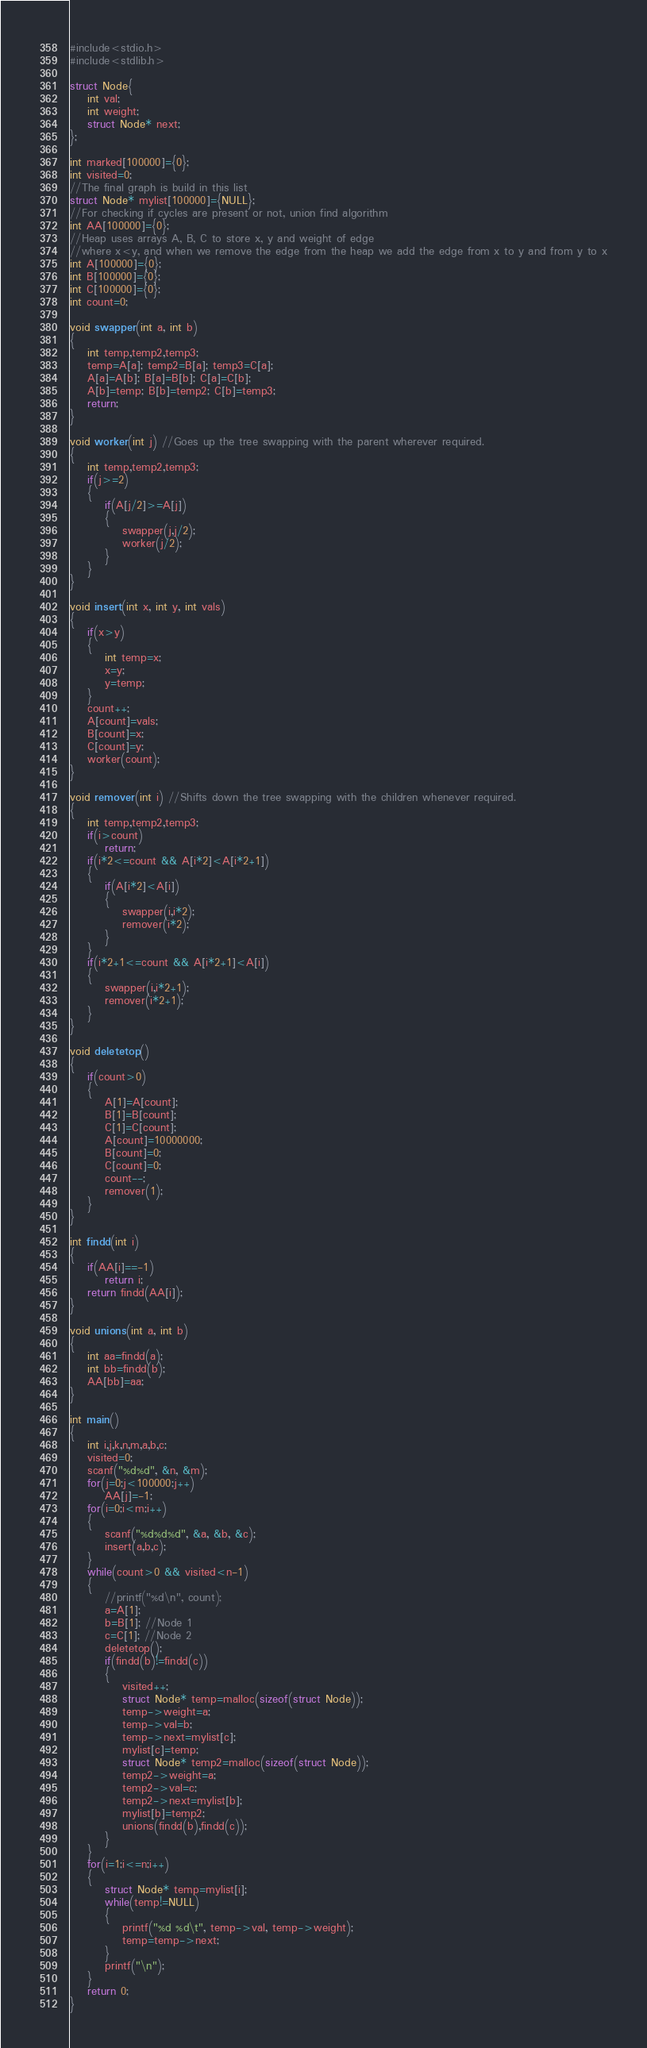Convert code to text. <code><loc_0><loc_0><loc_500><loc_500><_C_>#include<stdio.h>
#include<stdlib.h>

struct Node{
	int val;
	int weight;
	struct Node* next;
};

int marked[100000]={0};
int visited=0;
//The final graph is build in this list
struct Node* mylist[100000]={NULL};
//For checking if cycles are present or not, union find algorithm
int AA[100000]={0};
//Heap uses arrays A, B, C to store x, y and weight of edge
//where x<y, and when we remove the edge from the heap we add the edge from x to y and from y to x
int A[100000]={0};
int B[100000]={0};
int C[100000]={0};
int count=0;

void swapper(int a, int b)
{
	int temp,temp2,temp3;
	temp=A[a]; temp2=B[a]; temp3=C[a];
	A[a]=A[b]; B[a]=B[b]; C[a]=C[b];
	A[b]=temp; B[b]=temp2; C[b]=temp3;
	return;
}

void worker(int j) //Goes up the tree swapping with the parent wherever required.
{
	int temp,temp2,temp3;
	if(j>=2)
	{
		if(A[j/2]>=A[j])
		{
			swapper(j,j/2);
			worker(j/2);
		}
	}
}

void insert(int x, int y, int vals)
{
	if(x>y)
	{
		int temp=x;
		x=y;
		y=temp;
	}
	count++;
	A[count]=vals;
	B[count]=x;
	C[count]=y;
	worker(count);
}

void remover(int i) //Shifts down the tree swapping with the children whenever required.
{
	int temp,temp2,temp3;
	if(i>count)
		return;
	if(i*2<=count && A[i*2]<A[i*2+1])
	{
		if(A[i*2]<A[i])
		{
			swapper(i,i*2);
			remover(i*2);
		}
	}
	if(i*2+1<=count && A[i*2+1]<A[i])
	{
		swapper(i,i*2+1);
		remover(i*2+1);
	}
}

void deletetop()
{
	if(count>0)
	{
		A[1]=A[count];
		B[1]=B[count];
		C[1]=C[count];
		A[count]=10000000;
		B[count]=0;
		C[count]=0;
		count--;
		remover(1);
	}
}

int findd(int i)
{
	if(AA[i]==-1)
		return i;
	return findd(AA[i]);
}

void unions(int a, int b)
{
	int aa=findd(a);
	int bb=findd(b);
	AA[bb]=aa;
}

int main()
{
	int i,j,k,n,m,a,b,c;
	visited=0;
	scanf("%d%d", &n, &m);
	for(j=0;j<100000;j++)
		AA[j]=-1;
	for(i=0;i<m;i++)
	{
		scanf("%d%d%d", &a, &b, &c);
		insert(a,b,c);
	}
	while(count>0 && visited<n-1)
	{
		//printf("%d\n", count);
		a=A[1];
		b=B[1]; //Node 1
		c=C[1]; //Node 2
		deletetop();
		if(findd(b)!=findd(c))
		{
			visited++;
			struct Node* temp=malloc(sizeof(struct Node));
			temp->weight=a;
			temp->val=b;
			temp->next=mylist[c];
			mylist[c]=temp;
			struct Node* temp2=malloc(sizeof(struct Node));
			temp2->weight=a;
			temp2->val=c;
			temp2->next=mylist[b];
			mylist[b]=temp2;
			unions(findd(b),findd(c));
		}
	}
	for(i=1;i<=n;i++)
	{
		struct Node* temp=mylist[i];
		while(temp!=NULL)
		{
			printf("%d %d\t", temp->val, temp->weight);
			temp=temp->next;
		}
		printf("\n");
	}
	return 0;
}
</code> 